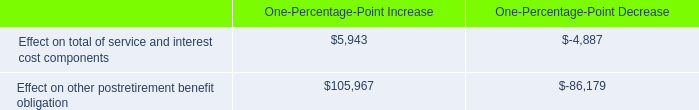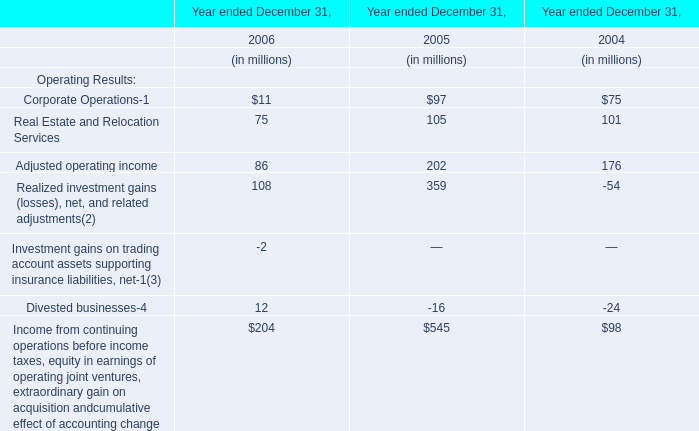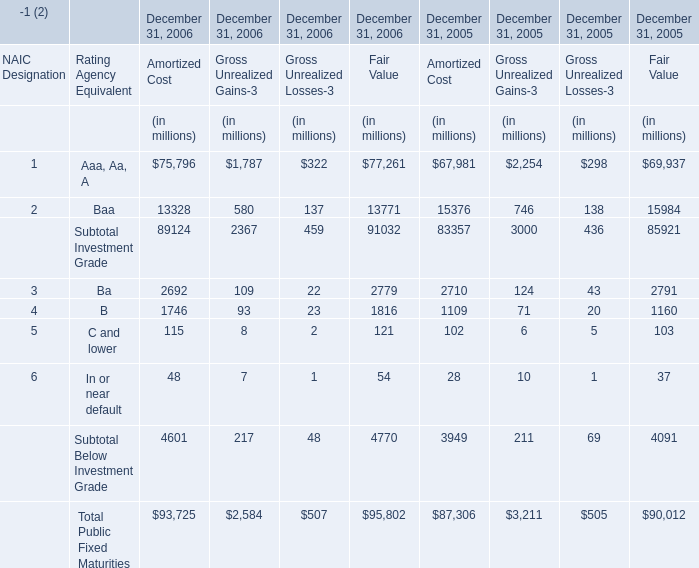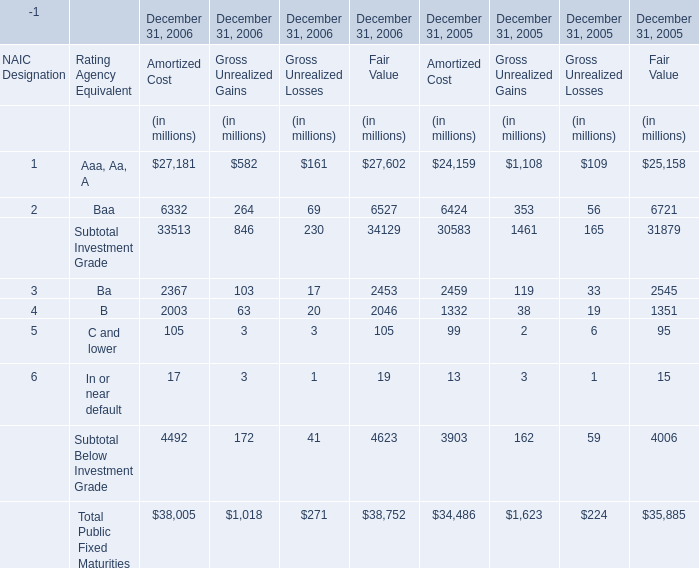At December 31,what year is Gross Unrealized Gains for Subtotal Investment Grade greater than 1000 million? 
Answer: 2005. 